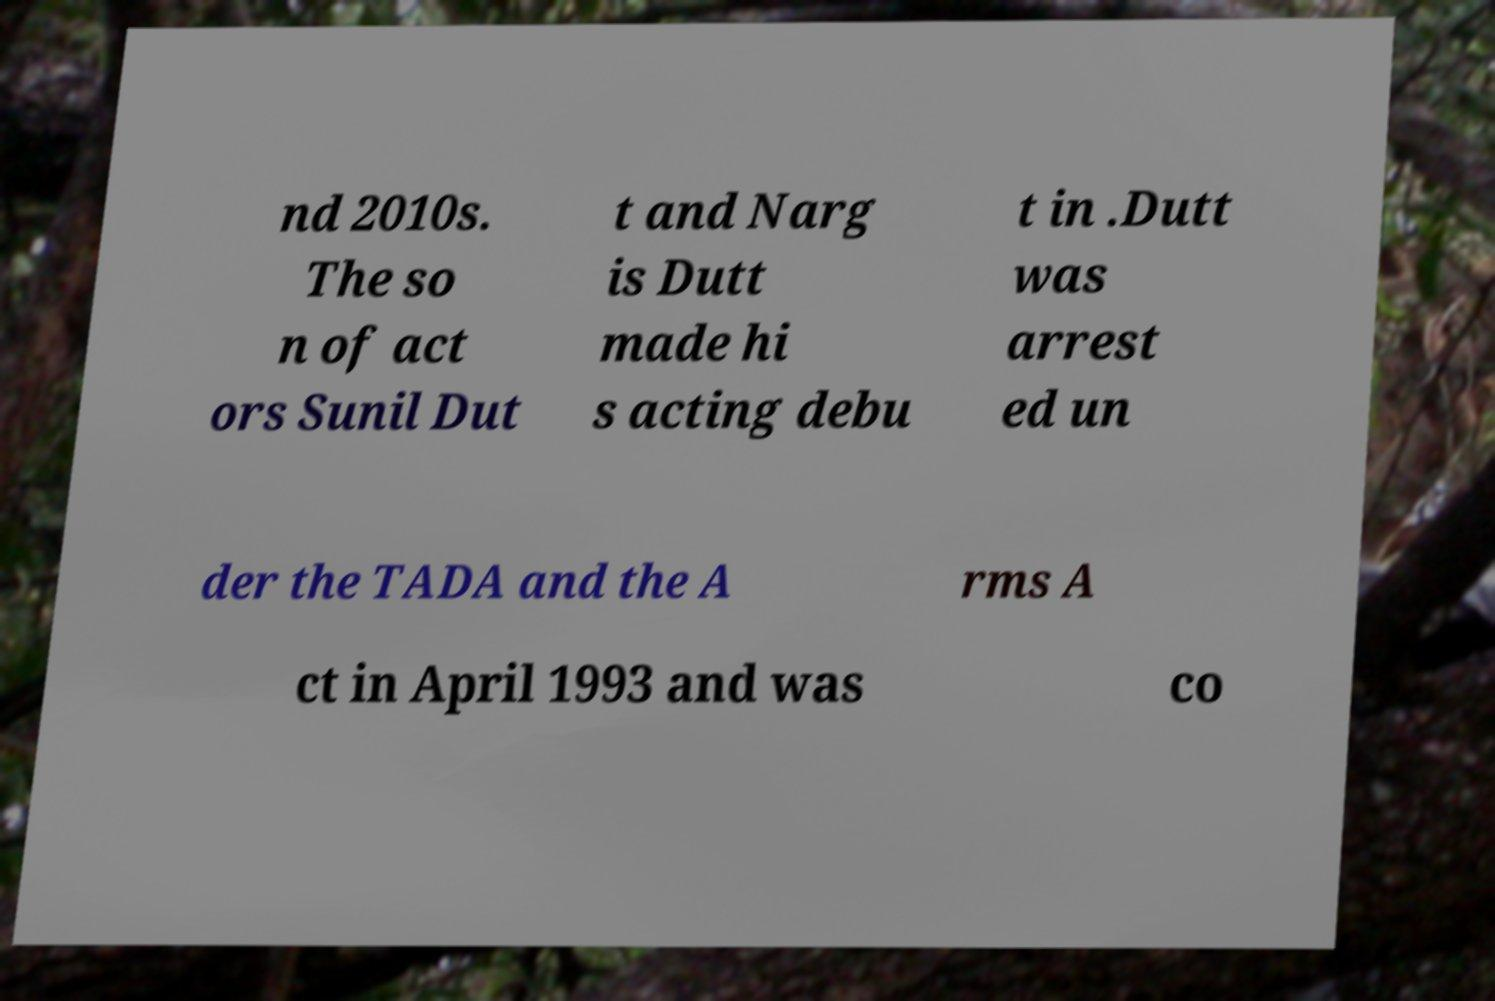Please read and relay the text visible in this image. What does it say? nd 2010s. The so n of act ors Sunil Dut t and Narg is Dutt made hi s acting debu t in .Dutt was arrest ed un der the TADA and the A rms A ct in April 1993 and was co 